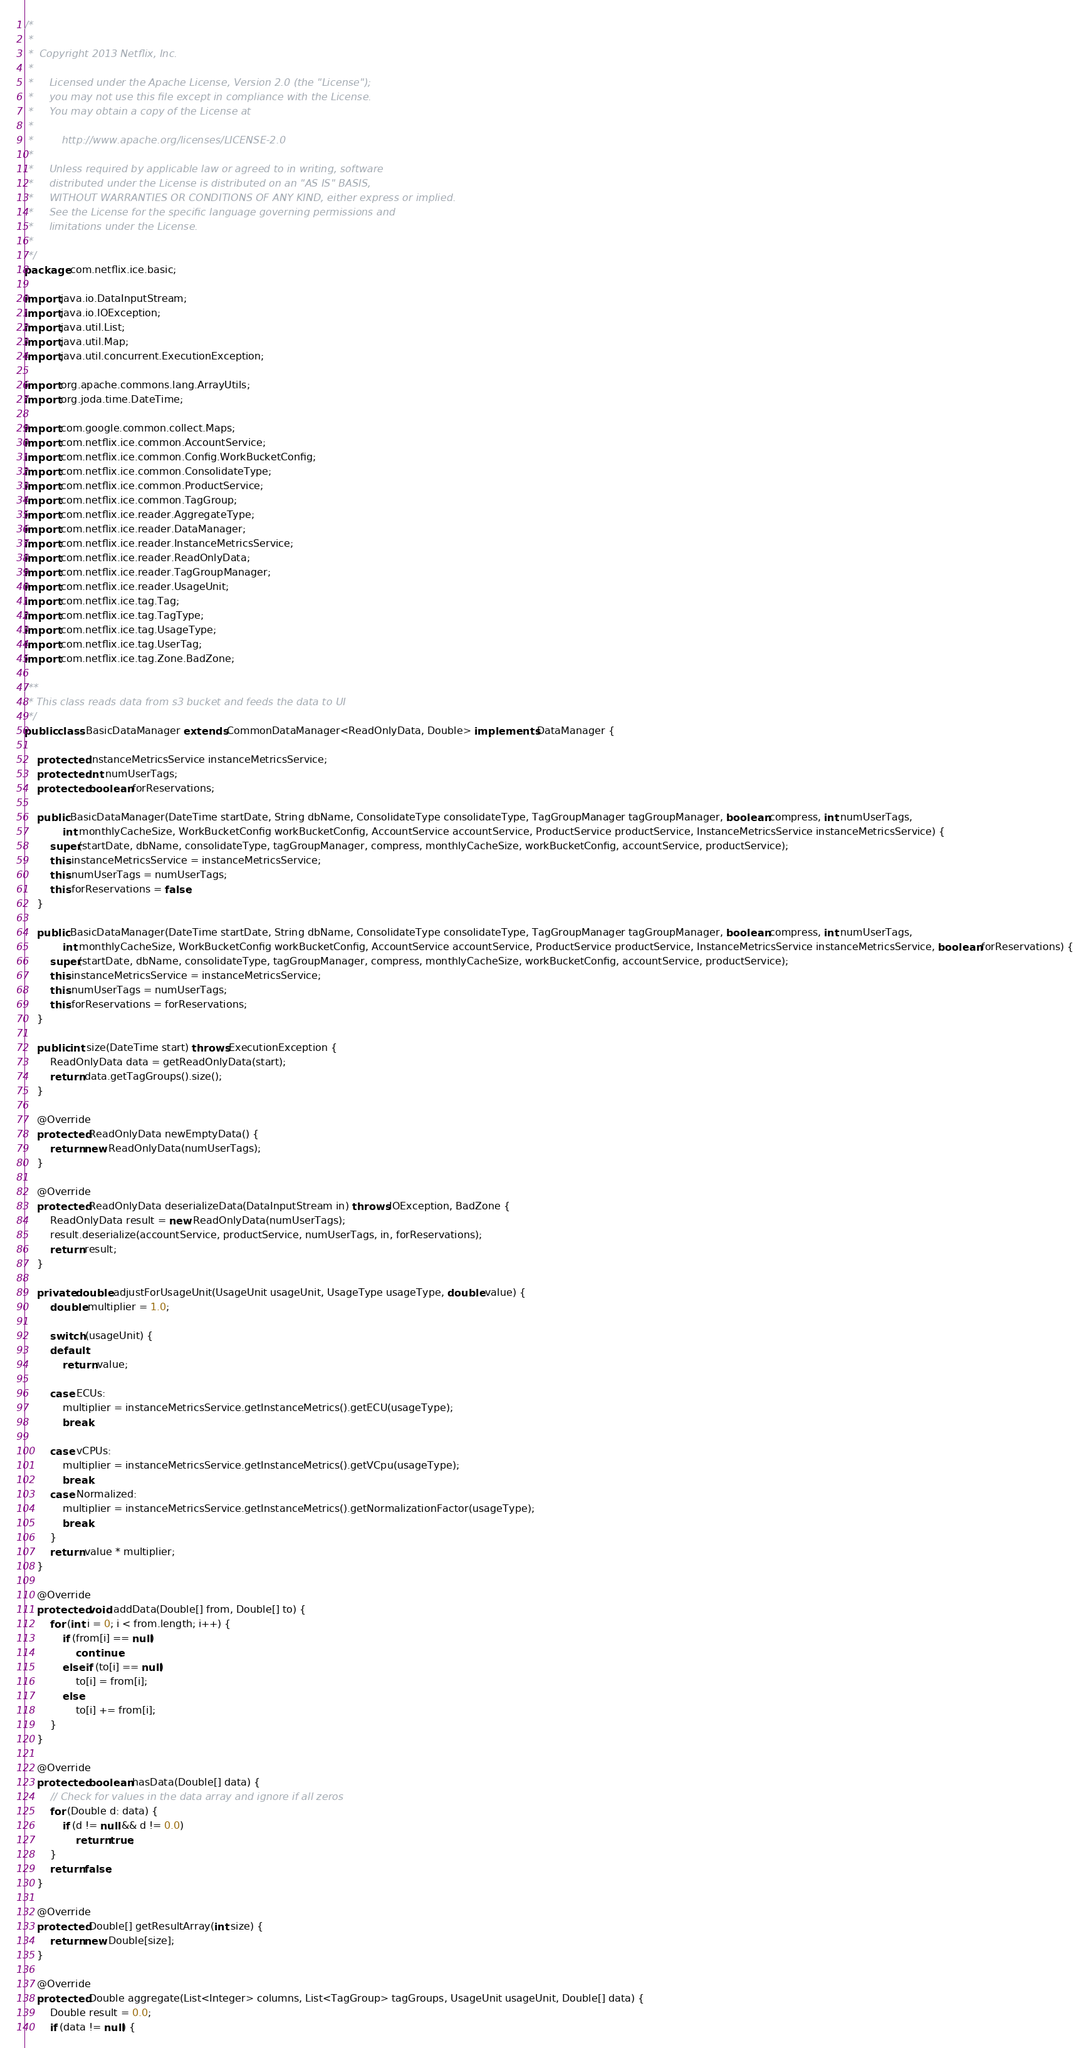<code> <loc_0><loc_0><loc_500><loc_500><_Java_>/*
 *
 *  Copyright 2013 Netflix, Inc.
 *
 *     Licensed under the Apache License, Version 2.0 (the "License");
 *     you may not use this file except in compliance with the License.
 *     You may obtain a copy of the License at
 *
 *         http://www.apache.org/licenses/LICENSE-2.0
 *
 *     Unless required by applicable law or agreed to in writing, software
 *     distributed under the License is distributed on an "AS IS" BASIS,
 *     WITHOUT WARRANTIES OR CONDITIONS OF ANY KIND, either express or implied.
 *     See the License for the specific language governing permissions and
 *     limitations under the License.
 *
 */
package com.netflix.ice.basic;

import java.io.DataInputStream;
import java.io.IOException;
import java.util.List;
import java.util.Map;
import java.util.concurrent.ExecutionException;

import org.apache.commons.lang.ArrayUtils;
import org.joda.time.DateTime;

import com.google.common.collect.Maps;
import com.netflix.ice.common.AccountService;
import com.netflix.ice.common.Config.WorkBucketConfig;
import com.netflix.ice.common.ConsolidateType;
import com.netflix.ice.common.ProductService;
import com.netflix.ice.common.TagGroup;
import com.netflix.ice.reader.AggregateType;
import com.netflix.ice.reader.DataManager;
import com.netflix.ice.reader.InstanceMetricsService;
import com.netflix.ice.reader.ReadOnlyData;
import com.netflix.ice.reader.TagGroupManager;
import com.netflix.ice.reader.UsageUnit;
import com.netflix.ice.tag.Tag;
import com.netflix.ice.tag.TagType;
import com.netflix.ice.tag.UsageType;
import com.netflix.ice.tag.UserTag;
import com.netflix.ice.tag.Zone.BadZone;

/**
 * This class reads data from s3 bucket and feeds the data to UI
 */
public class BasicDataManager extends CommonDataManager<ReadOnlyData, Double> implements DataManager {

    protected InstanceMetricsService instanceMetricsService;
    protected int numUserTags;
    protected boolean forReservations;
    
    public BasicDataManager(DateTime startDate, String dbName, ConsolidateType consolidateType, TagGroupManager tagGroupManager, boolean compress, int numUserTags,
    		int monthlyCacheSize, WorkBucketConfig workBucketConfig, AccountService accountService, ProductService productService, InstanceMetricsService instanceMetricsService) {
    	super(startDate, dbName, consolidateType, tagGroupManager, compress, monthlyCacheSize, workBucketConfig, accountService, productService);
        this.instanceMetricsService = instanceMetricsService;
        this.numUserTags = numUserTags;
        this.forReservations = false;
    }
    	
    public BasicDataManager(DateTime startDate, String dbName, ConsolidateType consolidateType, TagGroupManager tagGroupManager, boolean compress, int numUserTags,
    		int monthlyCacheSize, WorkBucketConfig workBucketConfig, AccountService accountService, ProductService productService, InstanceMetricsService instanceMetricsService, boolean forReservations) {
    	super(startDate, dbName, consolidateType, tagGroupManager, compress, monthlyCacheSize, workBucketConfig, accountService, productService);
        this.instanceMetricsService = instanceMetricsService;
        this.numUserTags = numUserTags;
        this.forReservations = forReservations;
    }
    	
	public int size(DateTime start) throws ExecutionException {
		ReadOnlyData data = getReadOnlyData(start);
		return data.getTagGroups().size();
	}
	
    @Override
    protected ReadOnlyData newEmptyData() {
    	return new ReadOnlyData(numUserTags);
    }

    @Override
    protected ReadOnlyData deserializeData(DataInputStream in) throws IOException, BadZone {
	    ReadOnlyData result = new ReadOnlyData(numUserTags);
	    result.deserialize(accountService, productService, numUserTags, in, forReservations);
	    return result;
    }
            
    private double adjustForUsageUnit(UsageUnit usageUnit, UsageType usageType, double value) {
    	double multiplier = 1.0;
    	
    	switch (usageUnit) {
    	default:
    		return value;
    	
    	case ECUs:
    		multiplier = instanceMetricsService.getInstanceMetrics().getECU(usageType);
    		break;
    		
    	case vCPUs:
    		multiplier = instanceMetricsService.getInstanceMetrics().getVCpu(usageType);
    		break;
    	case Normalized:
    		multiplier = instanceMetricsService.getInstanceMetrics().getNormalizationFactor(usageType);
    		break;
    	}
    	return value * multiplier;    		
    }

	@Override
    protected void addData(Double[] from, Double[] to) {
        for (int i = 0; i < from.length; i++) {
        	if (from[i] == null)
        		continue;
        	else if (to[i] == null)
        		to[i] = from[i];
        	else
        		to[i] += from[i];
        }
    }
	
    @Override
    protected boolean hasData(Double[] data) {
    	// Check for values in the data array and ignore if all zeros
    	for (Double d: data) {
    		if (d != null && d != 0.0)
    			return true;
    	}
    	return false;
    }

	@Override
	protected Double[] getResultArray(int size) {
        return new Double[size];
	}

	@Override
    protected Double aggregate(List<Integer> columns, List<TagGroup> tagGroups, UsageUnit usageUnit, Double[] data) {
		Double result = 0.0;
		if (data != null) {</code> 